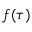<formula> <loc_0><loc_0><loc_500><loc_500>f ( \tau )</formula> 